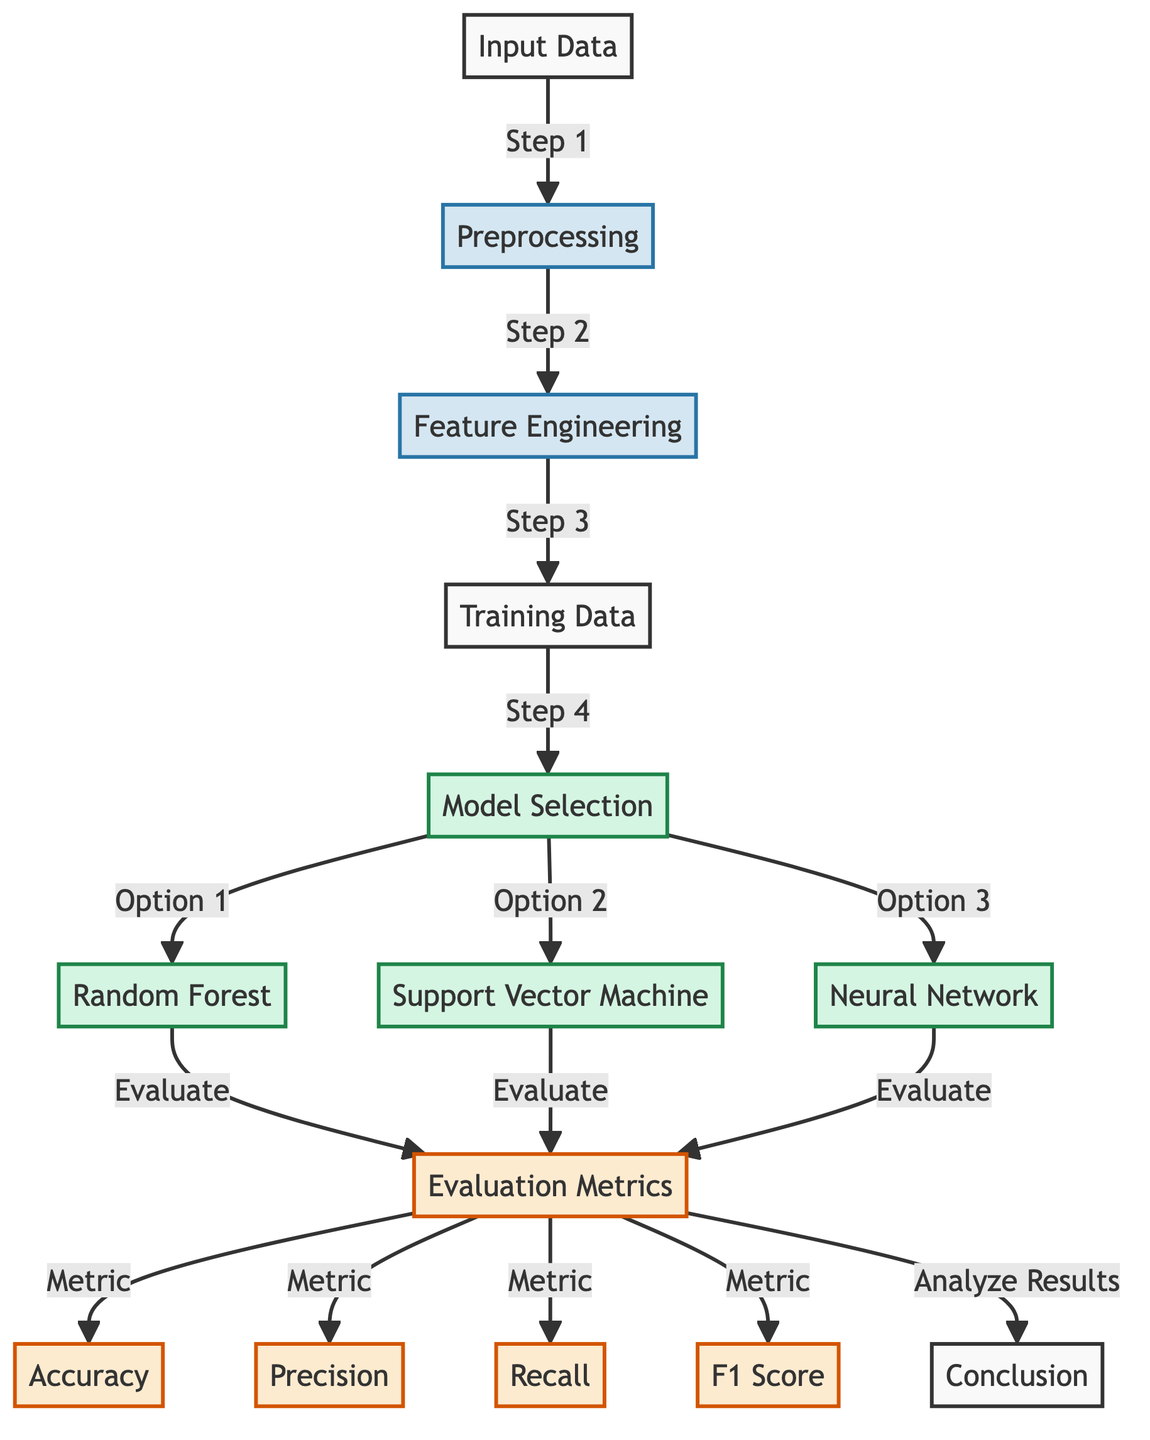What is the first step depicted in the diagram? The diagram indicates that the first step after the input data is preprocessing. I found this by following the arrows from the 'Input Data' node, which points to the 'Preprocessing' node directly.
Answer: preprocessing How many machine learning models are selected for evaluation in the diagram? There are three machine learning models specified: Random Forest, Support Vector Machine, and Neural Network. I counted the model nodes that branch out from the 'Model Selection' node to determine this number.
Answer: three What evaluation metric is shown last in the flow? The last evaluation metric in the flow is F1 Score, as indicated by the sequential arrows leading from the 'Evaluation Metrics' node. The flow leads from the evaluation node to accuracy, precision, recall, and finally ends at F1 Score.
Answer: F1 Score Which process follows feature engineering in the diagram? After feature engineering, the next process indicated is the preparation of training data. I identified this progression by tracing the arrows from the 'Feature Engineering' node to the 'Training Data' node.
Answer: training data Which machine learning model is the second option for selection? The second model option for selection is the Support Vector Machine, which is designated as 'Option 2' under the 'Model Selection' node. I found this by reviewing the branching options under model selection and their ordering.
Answer: Support Vector Machine How many evaluation metrics are shown in the diagram? The diagram shows four evaluation metrics: Accuracy, Precision, Recall, and F1 Score. These metrics are represented by individual nodes that branch out from the evaluation node, which makes it easy to count them.
Answer: four What is the concluding step after evaluating the models? The concluding step after the evaluation is reaching a conclusion, as indicated by the arrow leading to the 'Conclusion' node from the 'Analyze Results' label.
Answer: conclusion What is the process that directly leads to model selection? The process that leads to model selection directly is the preparation of training data. I traced the flow from 'Training Data' to 'Model Selection' to confirm this relation.
Answer: training data 